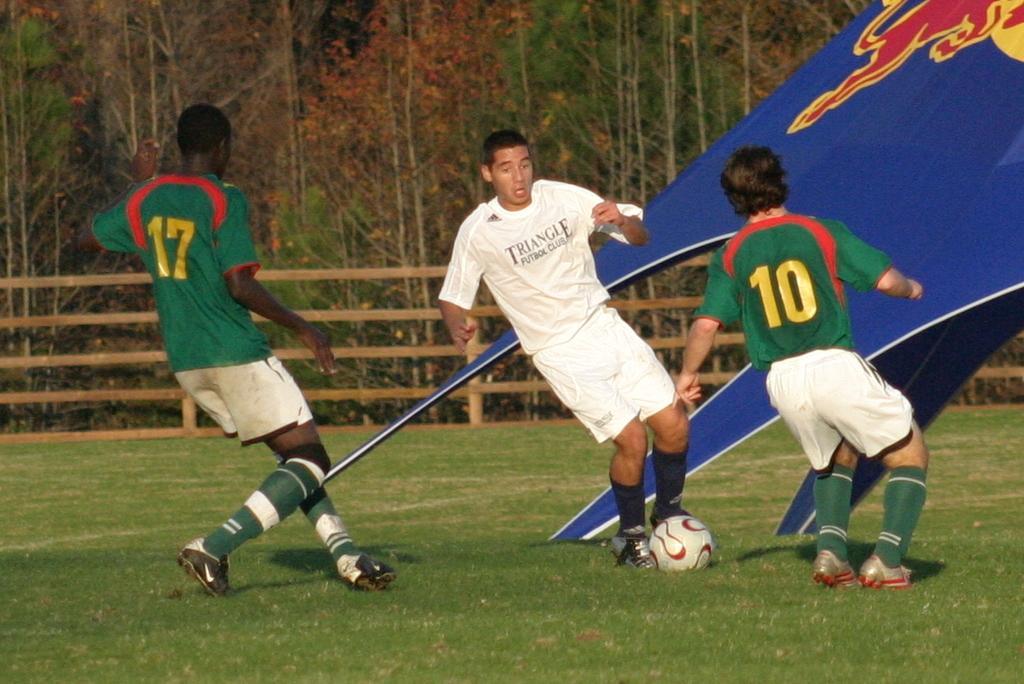How would you summarize this image in a sentence or two? This picture is clicked in a ground. Here, we see three men playing football. Man in white T-shirt is kicking football. Beside them, we see a board which is in white, blue color and behind them, we see wooden fence and behind that, we see many trees. 